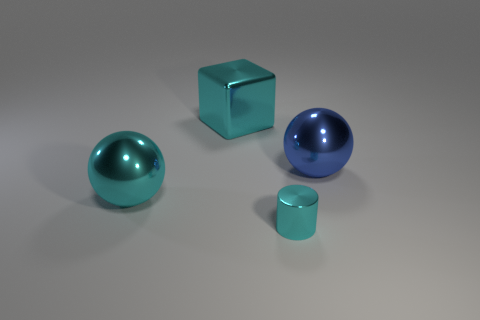Is the color of the cube the same as the tiny cylinder?
Give a very brief answer. Yes. What shape is the blue metallic object?
Ensure brevity in your answer.  Sphere. What size is the object that is in front of the cyan metal block and left of the cylinder?
Keep it short and to the point. Large. Do the big cube and the large metallic ball that is left of the cylinder have the same color?
Ensure brevity in your answer.  Yes. How many objects are either cyan metal things that are in front of the large cyan shiny cube or things that are left of the large cyan cube?
Make the answer very short. 2. What is the color of the metal thing that is in front of the big blue object and to the left of the small cyan shiny cylinder?
Provide a short and direct response. Cyan. Are there more large shiny blocks than small red things?
Offer a terse response. Yes. Does the big cyan object that is in front of the blue sphere have the same shape as the blue thing?
Give a very brief answer. Yes. What number of metallic objects are cyan things or large blue spheres?
Your response must be concise. 4. Are there any cylinders made of the same material as the big cyan sphere?
Keep it short and to the point. Yes. 